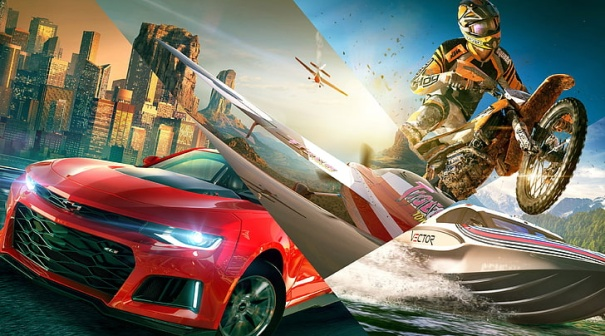What kind of event might be taking place in this image? The image could be depicting an exhilarating extreme sports event, perhaps a high-stakes urban race combining different modes of transport such as cars, dirt bikes, and speedboats. The presence of helicopters might indicate official monitoring or media coverage of the event, adding to the sense of excitement and competition in a vibrant, bustling city. What do you think is the significance of the sword on the car's hood? The sword on the car's hood may symbolize power, speed, and precision. It could be a logo for a racing team, an iconic emblem, or a special design created to evoke a sense of strength and competitiveness, fitting well within the thrilling context of the scene. Imagine the story of the dirt bike rider. Why are they performing this jump? The dirt bike rider could be a professional stunt performer, participating in a daredevil show or competition. Their fearless leap might be part of an attempt to set a new world record or to impress a large audience gathered in the city. Alternatively, they might be escaping or chasing someone in a high-octane action movie scene, where each move is crucial to the unfolding drama. What's the role of the helicopters in this scene? The helicopters could be serving multiple roles in this scene. They might be providing aerial footage for a live broadcast of the race or event, enhancing spectators' viewing experience. Alternatively, they could be part of a security detail ensuring the safety of participants and the audience, or they might be part of the action, possibly introducing an aerial challenge within the event. 